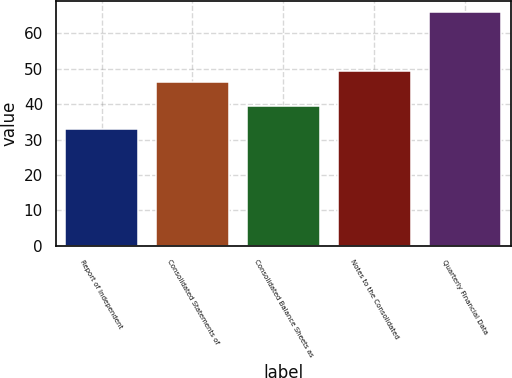<chart> <loc_0><loc_0><loc_500><loc_500><bar_chart><fcel>Report of Independent<fcel>Consolidated Statements of<fcel>Consolidated Balance Sheets as<fcel>Notes to the Consolidated<fcel>Quarterly Financial Data<nl><fcel>33<fcel>46.2<fcel>39.6<fcel>49.5<fcel>66<nl></chart> 